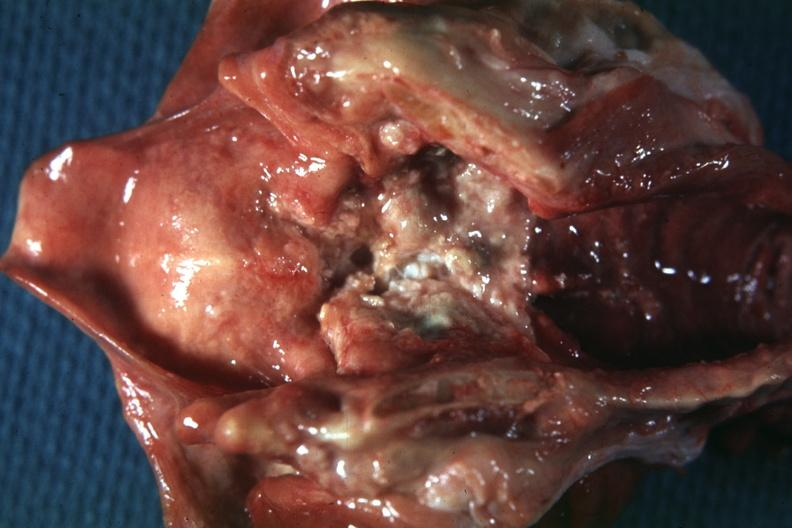s nodular tumor present?
Answer the question using a single word or phrase. No 